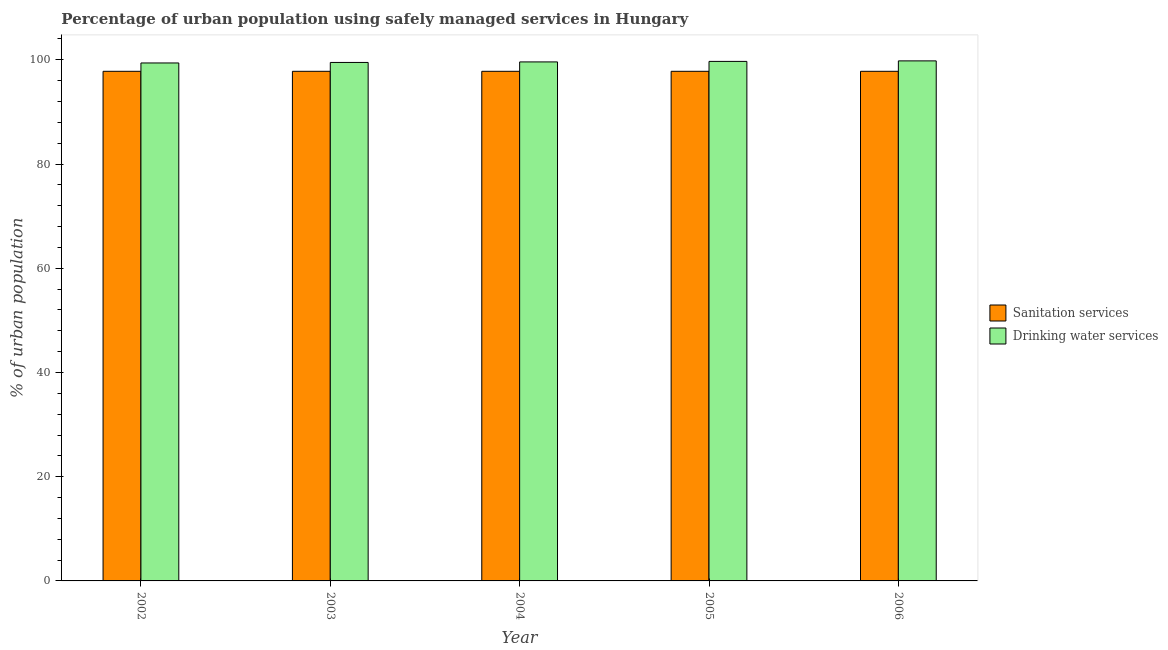Are the number of bars per tick equal to the number of legend labels?
Provide a short and direct response. Yes. What is the percentage of urban population who used drinking water services in 2003?
Your answer should be compact. 99.5. Across all years, what is the maximum percentage of urban population who used sanitation services?
Give a very brief answer. 97.8. Across all years, what is the minimum percentage of urban population who used sanitation services?
Offer a terse response. 97.8. What is the total percentage of urban population who used sanitation services in the graph?
Ensure brevity in your answer.  489. What is the difference between the percentage of urban population who used drinking water services in 2004 and that in 2005?
Provide a succinct answer. -0.1. What is the difference between the percentage of urban population who used drinking water services in 2005 and the percentage of urban population who used sanitation services in 2006?
Offer a terse response. -0.1. What is the average percentage of urban population who used drinking water services per year?
Offer a very short reply. 99.6. In the year 2003, what is the difference between the percentage of urban population who used sanitation services and percentage of urban population who used drinking water services?
Keep it short and to the point. 0. Is the difference between the percentage of urban population who used drinking water services in 2004 and 2006 greater than the difference between the percentage of urban population who used sanitation services in 2004 and 2006?
Make the answer very short. No. What is the difference between the highest and the second highest percentage of urban population who used drinking water services?
Give a very brief answer. 0.1. What is the difference between the highest and the lowest percentage of urban population who used drinking water services?
Offer a very short reply. 0.4. What does the 2nd bar from the left in 2003 represents?
Your response must be concise. Drinking water services. What does the 2nd bar from the right in 2005 represents?
Your answer should be compact. Sanitation services. What is the difference between two consecutive major ticks on the Y-axis?
Give a very brief answer. 20. Does the graph contain any zero values?
Your answer should be compact. No. How many legend labels are there?
Give a very brief answer. 2. What is the title of the graph?
Provide a short and direct response. Percentage of urban population using safely managed services in Hungary. What is the label or title of the Y-axis?
Ensure brevity in your answer.  % of urban population. What is the % of urban population of Sanitation services in 2002?
Offer a terse response. 97.8. What is the % of urban population of Drinking water services in 2002?
Provide a short and direct response. 99.4. What is the % of urban population of Sanitation services in 2003?
Your response must be concise. 97.8. What is the % of urban population of Drinking water services in 2003?
Your answer should be very brief. 99.5. What is the % of urban population of Sanitation services in 2004?
Keep it short and to the point. 97.8. What is the % of urban population in Drinking water services in 2004?
Your response must be concise. 99.6. What is the % of urban population of Sanitation services in 2005?
Your answer should be very brief. 97.8. What is the % of urban population in Drinking water services in 2005?
Your answer should be compact. 99.7. What is the % of urban population of Sanitation services in 2006?
Ensure brevity in your answer.  97.8. What is the % of urban population of Drinking water services in 2006?
Keep it short and to the point. 99.8. Across all years, what is the maximum % of urban population of Sanitation services?
Offer a very short reply. 97.8. Across all years, what is the maximum % of urban population of Drinking water services?
Make the answer very short. 99.8. Across all years, what is the minimum % of urban population in Sanitation services?
Your response must be concise. 97.8. Across all years, what is the minimum % of urban population of Drinking water services?
Make the answer very short. 99.4. What is the total % of urban population in Sanitation services in the graph?
Ensure brevity in your answer.  489. What is the total % of urban population of Drinking water services in the graph?
Offer a very short reply. 498. What is the difference between the % of urban population in Drinking water services in 2002 and that in 2003?
Offer a terse response. -0.1. What is the difference between the % of urban population of Sanitation services in 2002 and that in 2004?
Keep it short and to the point. 0. What is the difference between the % of urban population in Sanitation services in 2002 and that in 2005?
Make the answer very short. 0. What is the difference between the % of urban population of Drinking water services in 2002 and that in 2005?
Provide a short and direct response. -0.3. What is the difference between the % of urban population in Sanitation services in 2002 and that in 2006?
Offer a very short reply. 0. What is the difference between the % of urban population of Drinking water services in 2003 and that in 2006?
Give a very brief answer. -0.3. What is the difference between the % of urban population of Sanitation services in 2004 and that in 2005?
Ensure brevity in your answer.  0. What is the difference between the % of urban population in Sanitation services in 2004 and that in 2006?
Offer a very short reply. 0. What is the difference between the % of urban population of Sanitation services in 2005 and that in 2006?
Ensure brevity in your answer.  0. What is the difference between the % of urban population in Drinking water services in 2005 and that in 2006?
Your answer should be very brief. -0.1. What is the difference between the % of urban population in Sanitation services in 2002 and the % of urban population in Drinking water services in 2005?
Provide a succinct answer. -1.9. What is the difference between the % of urban population of Sanitation services in 2003 and the % of urban population of Drinking water services in 2006?
Your answer should be compact. -2. What is the difference between the % of urban population of Sanitation services in 2004 and the % of urban population of Drinking water services in 2006?
Your response must be concise. -2. What is the average % of urban population of Sanitation services per year?
Your answer should be compact. 97.8. What is the average % of urban population of Drinking water services per year?
Make the answer very short. 99.6. In the year 2002, what is the difference between the % of urban population in Sanitation services and % of urban population in Drinking water services?
Your answer should be compact. -1.6. In the year 2003, what is the difference between the % of urban population of Sanitation services and % of urban population of Drinking water services?
Keep it short and to the point. -1.7. What is the ratio of the % of urban population of Sanitation services in 2002 to that in 2003?
Provide a succinct answer. 1. What is the ratio of the % of urban population in Drinking water services in 2002 to that in 2004?
Provide a succinct answer. 1. What is the ratio of the % of urban population in Sanitation services in 2002 to that in 2005?
Offer a very short reply. 1. What is the ratio of the % of urban population of Drinking water services in 2003 to that in 2006?
Offer a terse response. 1. What is the ratio of the % of urban population in Drinking water services in 2004 to that in 2005?
Make the answer very short. 1. What is the ratio of the % of urban population in Drinking water services in 2004 to that in 2006?
Your answer should be compact. 1. What is the ratio of the % of urban population in Drinking water services in 2005 to that in 2006?
Offer a terse response. 1. What is the difference between the highest and the second highest % of urban population of Sanitation services?
Provide a succinct answer. 0. What is the difference between the highest and the second highest % of urban population in Drinking water services?
Your answer should be very brief. 0.1. 